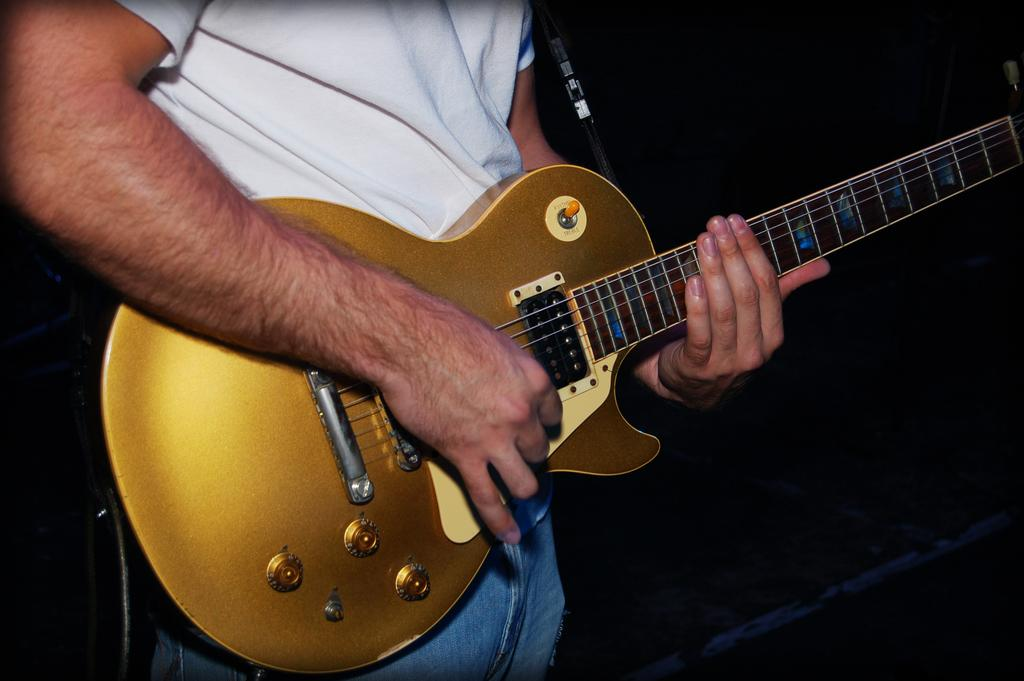What is the main subject of the image? There is a man in the image. What is the man wearing? The man is wearing a white shirt. What is the man holding in the image? The man is holding a guitar. What brand of toothpaste is the man using in the image? There is no toothpaste present in the image, and therefore no brand can be identified. 